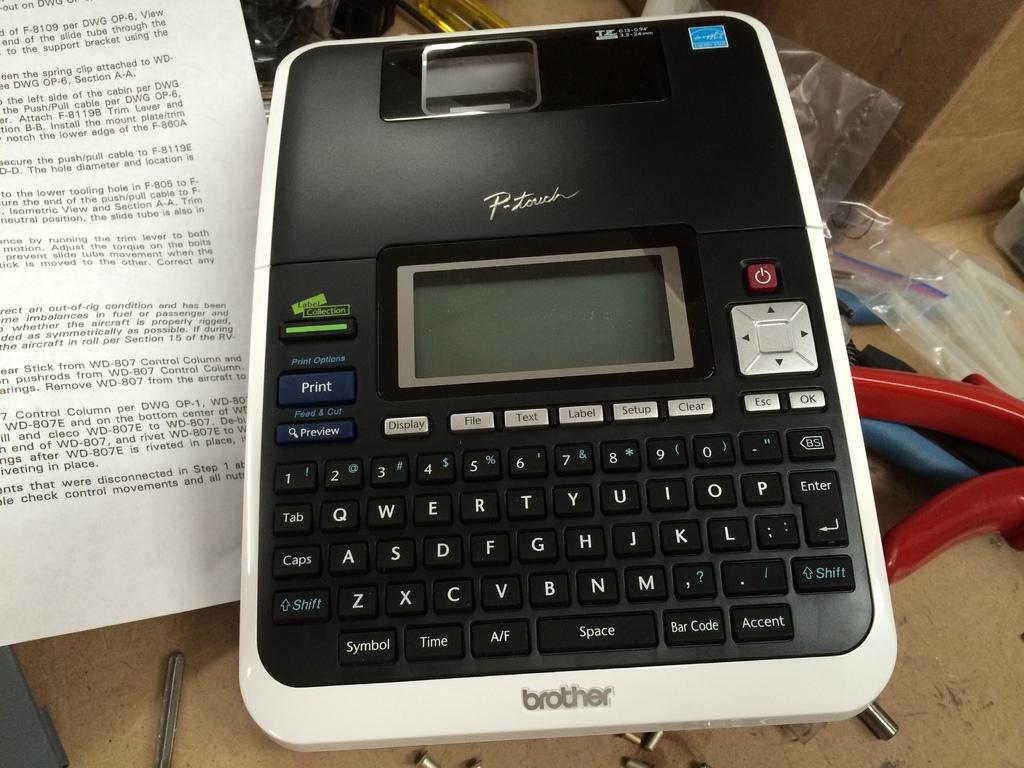What is the function listed on the bottom right key?
Keep it short and to the point. Accent. What brand of label maker is this?
Your answer should be very brief. Brother. 